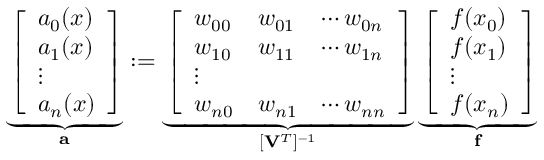Convert formula to latex. <formula><loc_0><loc_0><loc_500><loc_500>\underbrace { \left [ \begin{array} { l } { a _ { 0 } ( x ) } \\ { a _ { 1 } ( x ) } \\ { \vdots } \\ { a _ { n } ( x ) } \end{array} \right ] } _ { a } \colon = \underbrace { \left [ \begin{array} { l l l } { w _ { 0 0 } } & { w _ { 0 1 } } & { \cdots w _ { 0 n } } \\ { w _ { 1 0 } } & { w _ { 1 1 } } & { \cdots w _ { 1 n } } \\ { \vdots } \\ { w _ { n 0 } } & { w _ { n 1 } } & { \cdots w _ { n n } } \end{array} \right ] } _ { [ V ^ { T } ] ^ { - 1 } } \underbrace { \left [ \begin{array} { l } { f ( x _ { 0 } ) } \\ { f ( x _ { 1 } ) } \\ { \vdots } \\ { f ( x _ { n } ) } \end{array} \right ] } _ { f }</formula> 